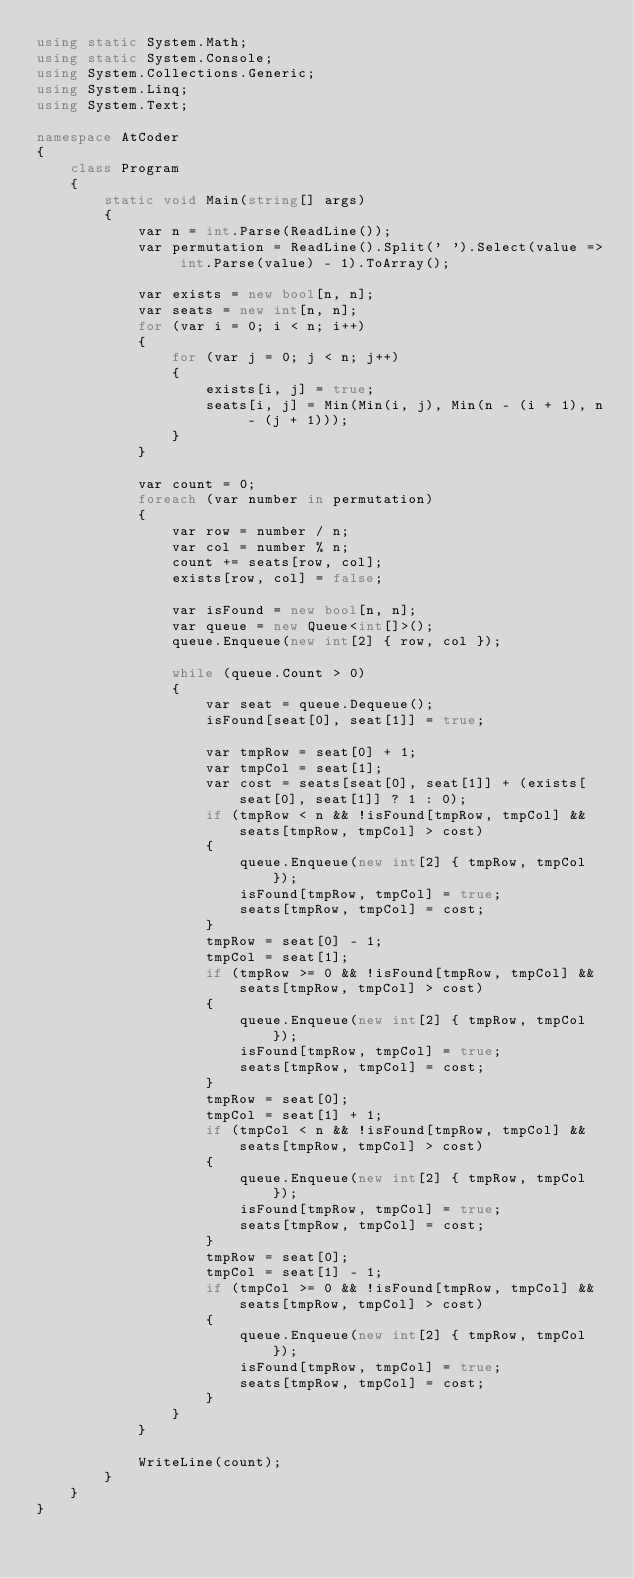<code> <loc_0><loc_0><loc_500><loc_500><_C#_>using static System.Math;
using static System.Console;
using System.Collections.Generic;
using System.Linq;
using System.Text;

namespace AtCoder
{
    class Program
    {
        static void Main(string[] args)
        {
            var n = int.Parse(ReadLine());
            var permutation = ReadLine().Split(' ').Select(value => int.Parse(value) - 1).ToArray();

            var exists = new bool[n, n];
            var seats = new int[n, n];
            for (var i = 0; i < n; i++)
            {
                for (var j = 0; j < n; j++)
                {
                    exists[i, j] = true;
                    seats[i, j] = Min(Min(i, j), Min(n - (i + 1), n - (j + 1)));
                }
            }

            var count = 0;
            foreach (var number in permutation)
            {
                var row = number / n;
                var col = number % n;
                count += seats[row, col];
                exists[row, col] = false;

                var isFound = new bool[n, n];
                var queue = new Queue<int[]>();
                queue.Enqueue(new int[2] { row, col });

                while (queue.Count > 0)
                {
                    var seat = queue.Dequeue();
                    isFound[seat[0], seat[1]] = true;

                    var tmpRow = seat[0] + 1;
                    var tmpCol = seat[1];
                    var cost = seats[seat[0], seat[1]] + (exists[seat[0], seat[1]] ? 1 : 0);
                    if (tmpRow < n && !isFound[tmpRow, tmpCol] && seats[tmpRow, tmpCol] > cost)
                    {
                        queue.Enqueue(new int[2] { tmpRow, tmpCol });
                        isFound[tmpRow, tmpCol] = true;
                        seats[tmpRow, tmpCol] = cost;
                    }
                    tmpRow = seat[0] - 1;
                    tmpCol = seat[1];
                    if (tmpRow >= 0 && !isFound[tmpRow, tmpCol] && seats[tmpRow, tmpCol] > cost)
                    {
                        queue.Enqueue(new int[2] { tmpRow, tmpCol });
                        isFound[tmpRow, tmpCol] = true;
                        seats[tmpRow, tmpCol] = cost;
                    }
                    tmpRow = seat[0];
                    tmpCol = seat[1] + 1;
                    if (tmpCol < n && !isFound[tmpRow, tmpCol] && seats[tmpRow, tmpCol] > cost)
                    {
                        queue.Enqueue(new int[2] { tmpRow, tmpCol });
                        isFound[tmpRow, tmpCol] = true;
                        seats[tmpRow, tmpCol] = cost;
                    }
                    tmpRow = seat[0];
                    tmpCol = seat[1] - 1;
                    if (tmpCol >= 0 && !isFound[tmpRow, tmpCol] && seats[tmpRow, tmpCol] > cost)
                    {
                        queue.Enqueue(new int[2] { tmpRow, tmpCol });
                        isFound[tmpRow, tmpCol] = true;
                        seats[tmpRow, tmpCol] = cost;
                    }
                }
            }

            WriteLine(count);
        }
    }
}
</code> 